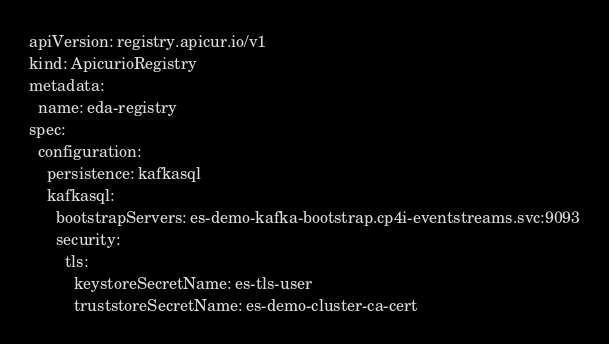Convert code to text. <code><loc_0><loc_0><loc_500><loc_500><_YAML_>apiVersion: registry.apicur.io/v1
kind: ApicurioRegistry
metadata:
  name: eda-registry
spec:
  configuration:
    persistence: kafkasql
    kafkasql:
      bootstrapServers: es-demo-kafka-bootstrap.cp4i-eventstreams.svc:9093
      security:
        tls:
          keystoreSecretName: es-tls-user
          truststoreSecretName: es-demo-cluster-ca-cert</code> 